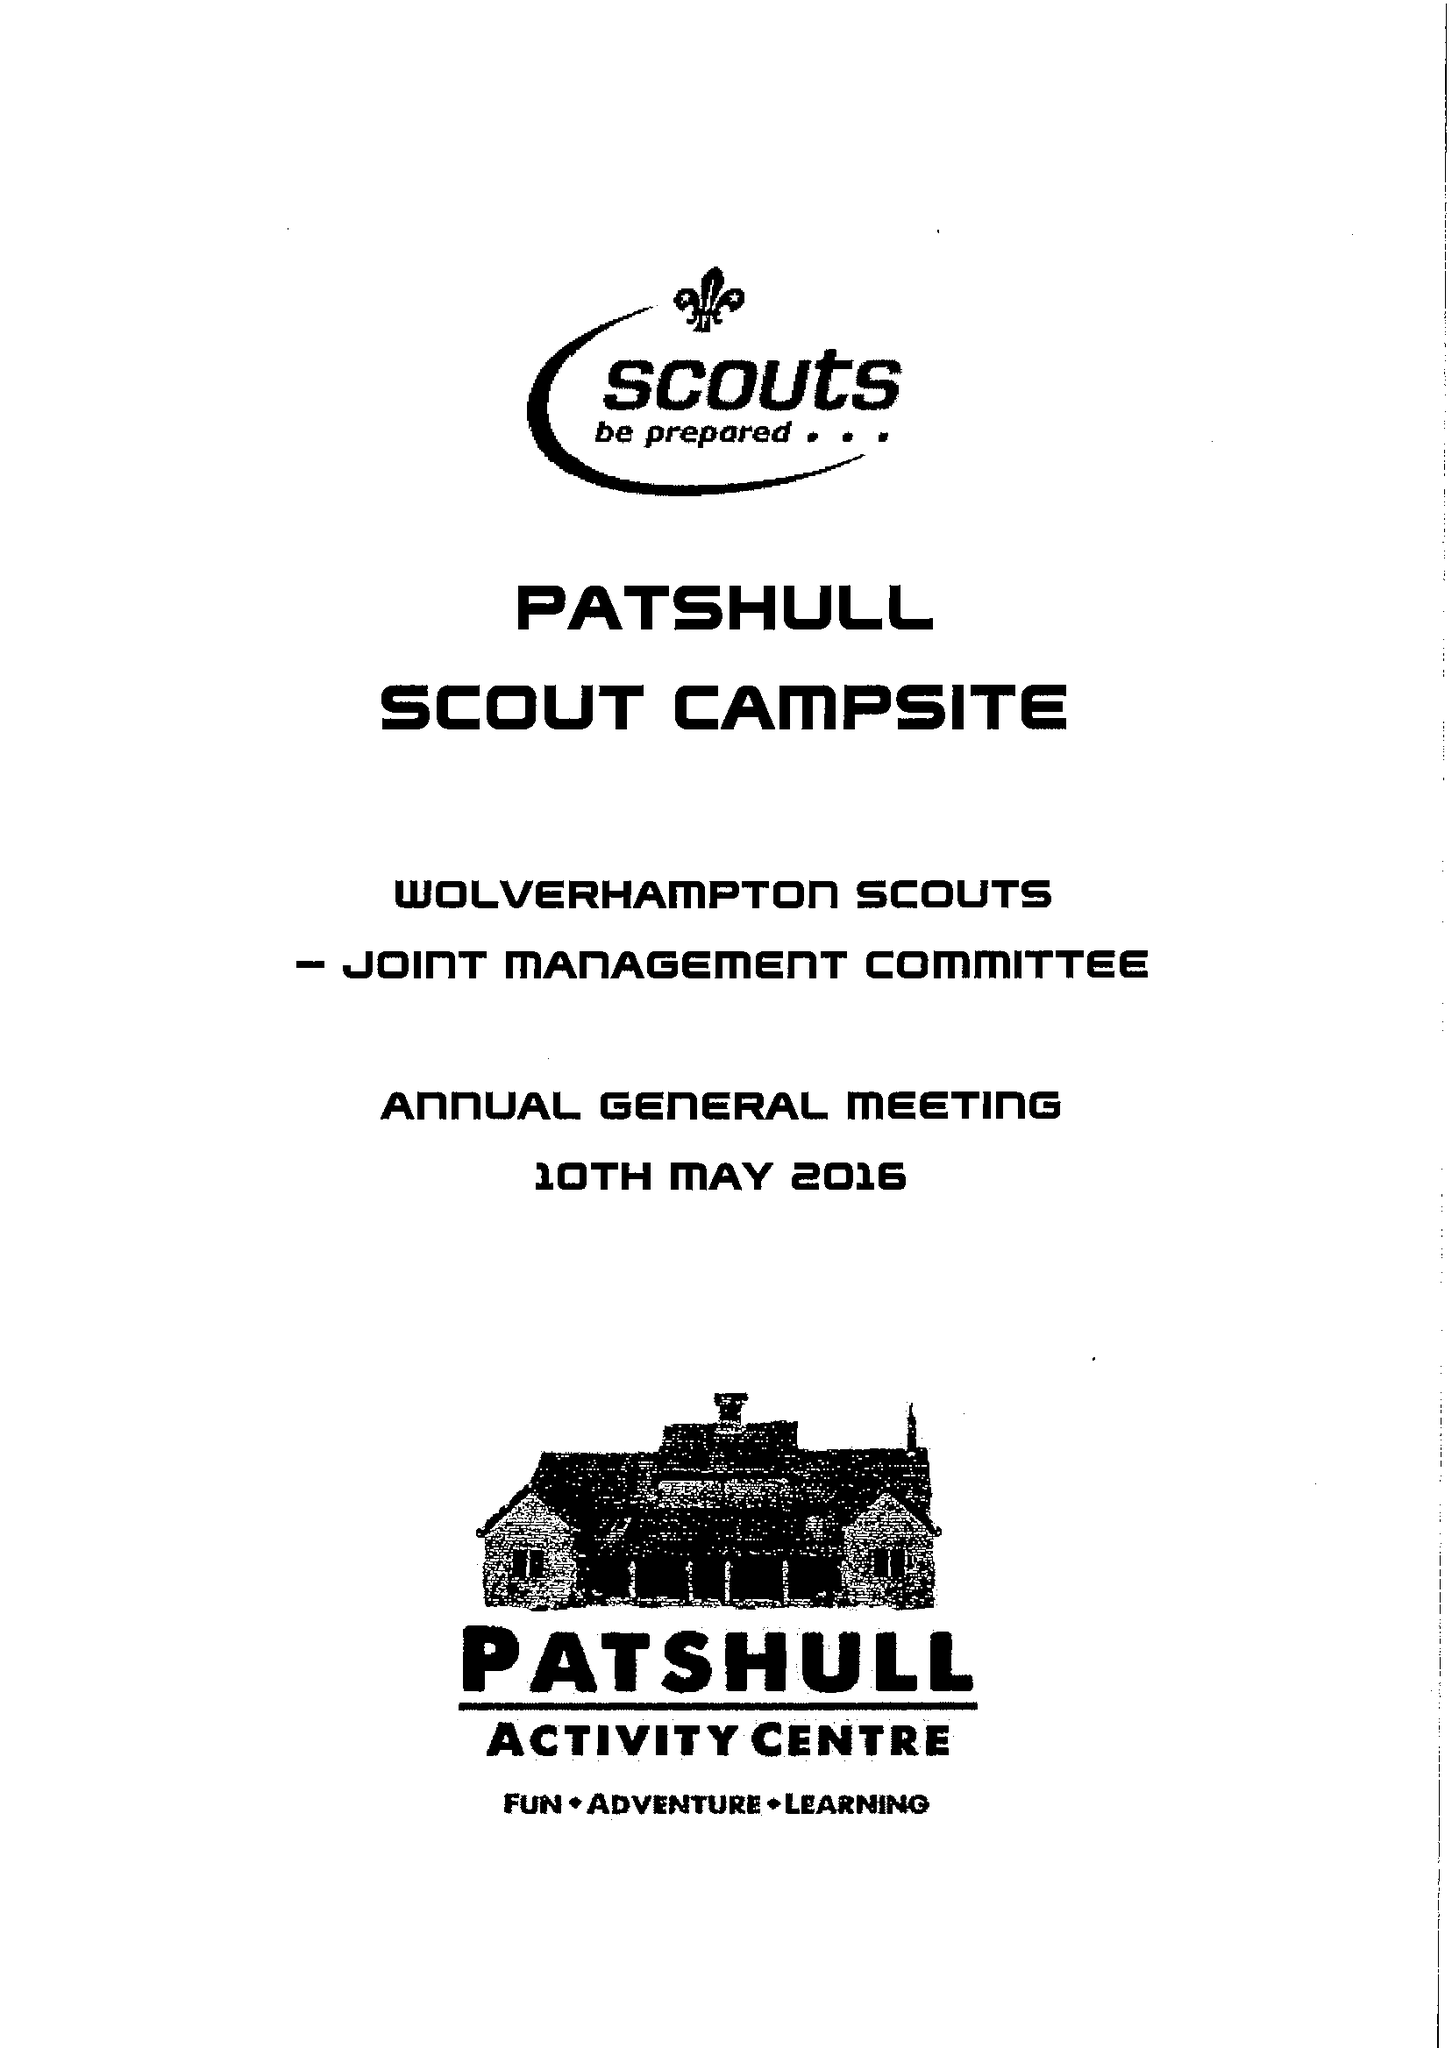What is the value for the income_annually_in_british_pounds?
Answer the question using a single word or phrase. 33108.00 